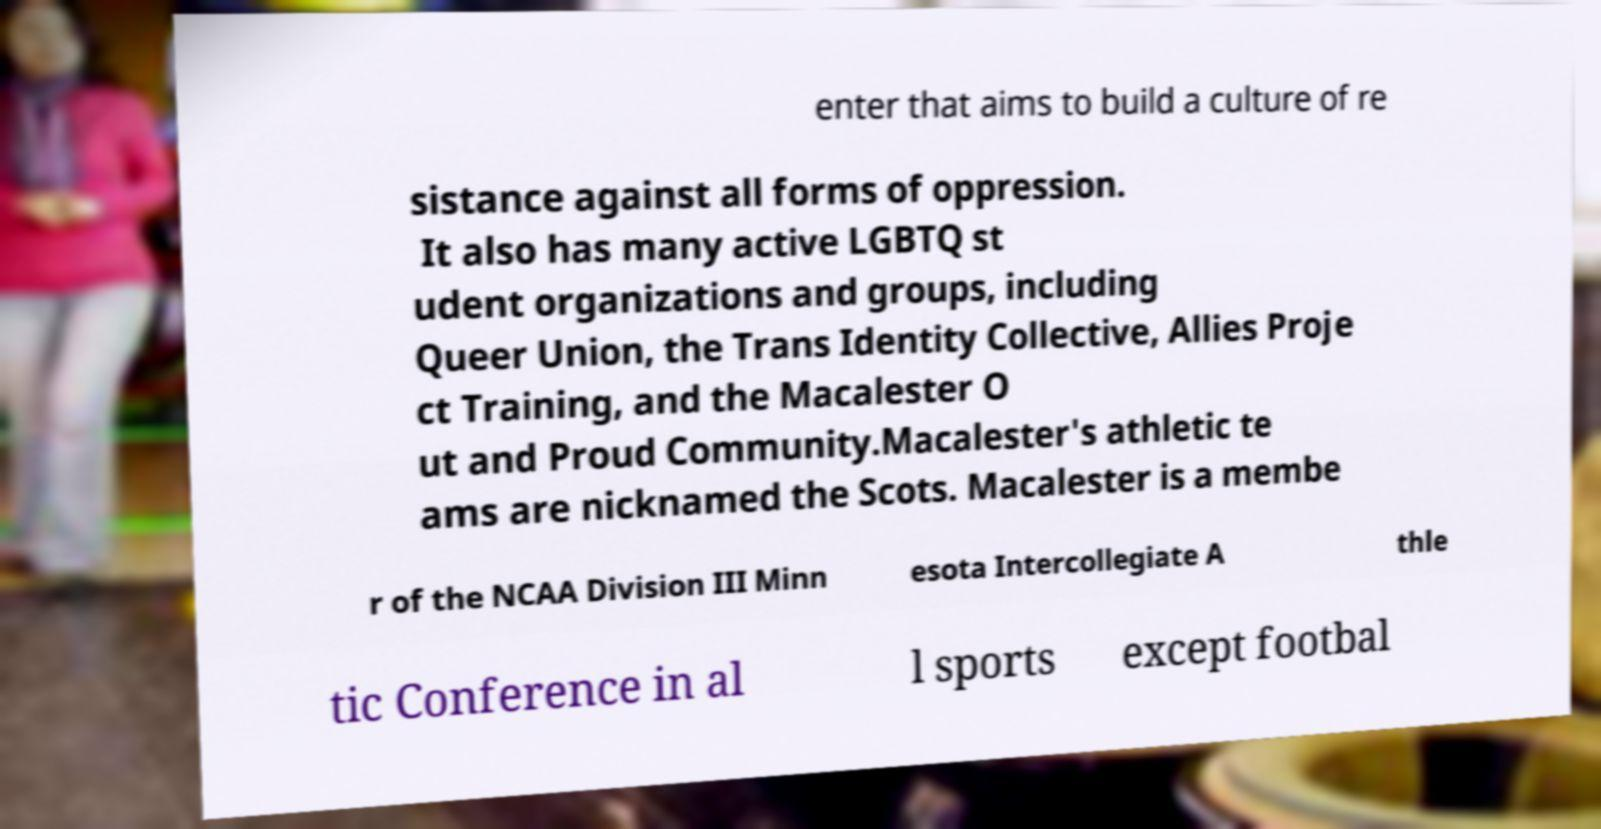Could you assist in decoding the text presented in this image and type it out clearly? enter that aims to build a culture of re sistance against all forms of oppression. It also has many active LGBTQ st udent organizations and groups, including Queer Union, the Trans Identity Collective, Allies Proje ct Training, and the Macalester O ut and Proud Community.Macalester's athletic te ams are nicknamed the Scots. Macalester is a membe r of the NCAA Division III Minn esota Intercollegiate A thle tic Conference in al l sports except footbal 